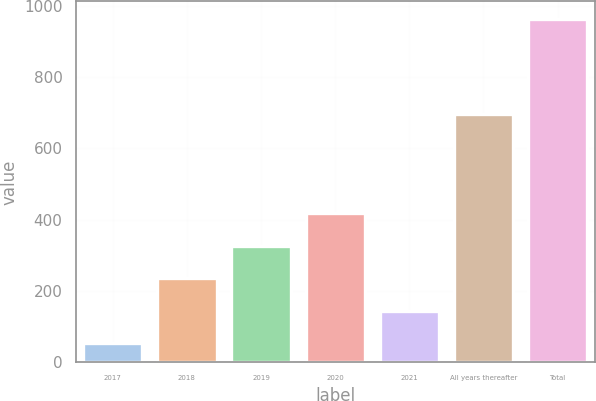<chart> <loc_0><loc_0><loc_500><loc_500><bar_chart><fcel>2017<fcel>2018<fcel>2019<fcel>2020<fcel>2021<fcel>All years thereafter<fcel>Total<nl><fcel>53<fcel>235.2<fcel>326.3<fcel>417.4<fcel>144.1<fcel>696<fcel>964<nl></chart> 